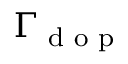Convert formula to latex. <formula><loc_0><loc_0><loc_500><loc_500>\Gamma _ { d o p }</formula> 